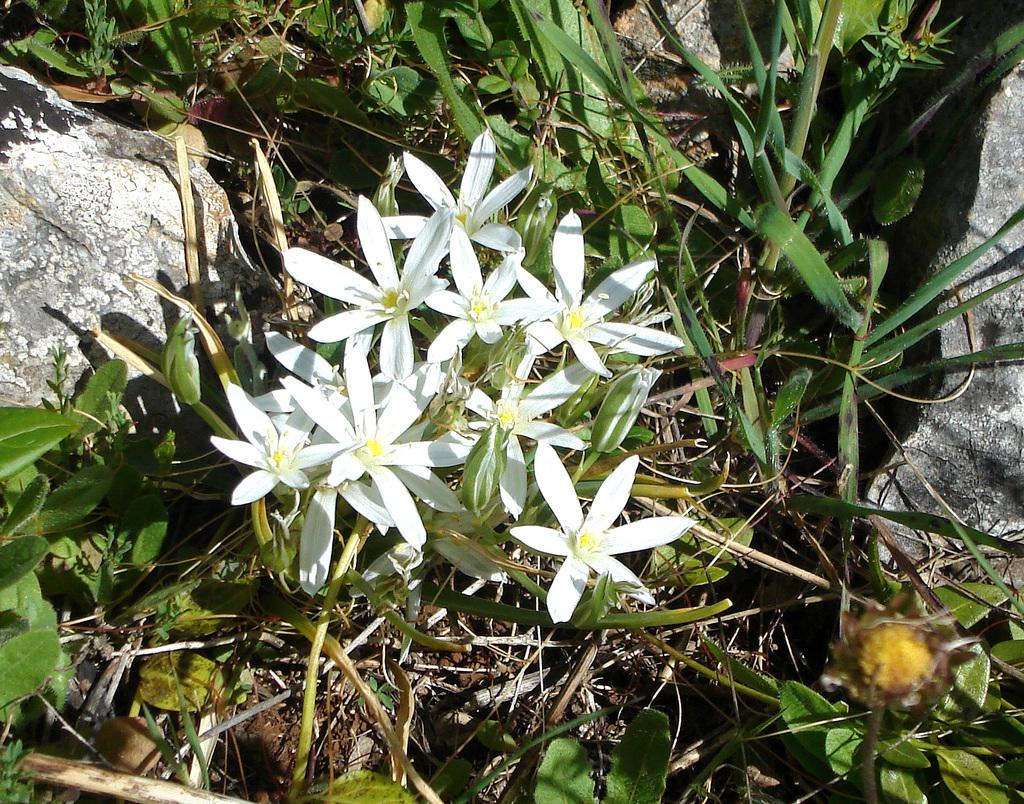What colors can be seen in the flowers in the image? The flowers in the image have white and yellow colors. What is the color of the leaves in the image? The leaves in the image are green. What other object can be seen in the image besides the flowers and leaves? There is a stone in the image. What type of book is being used as a prop in the image? There is no book present in the image; it features flowers, leaves, and a stone. What instrument is being played by the flowers in the image? There is no instrument present in the image, and flowers do not have the ability to play instruments. 